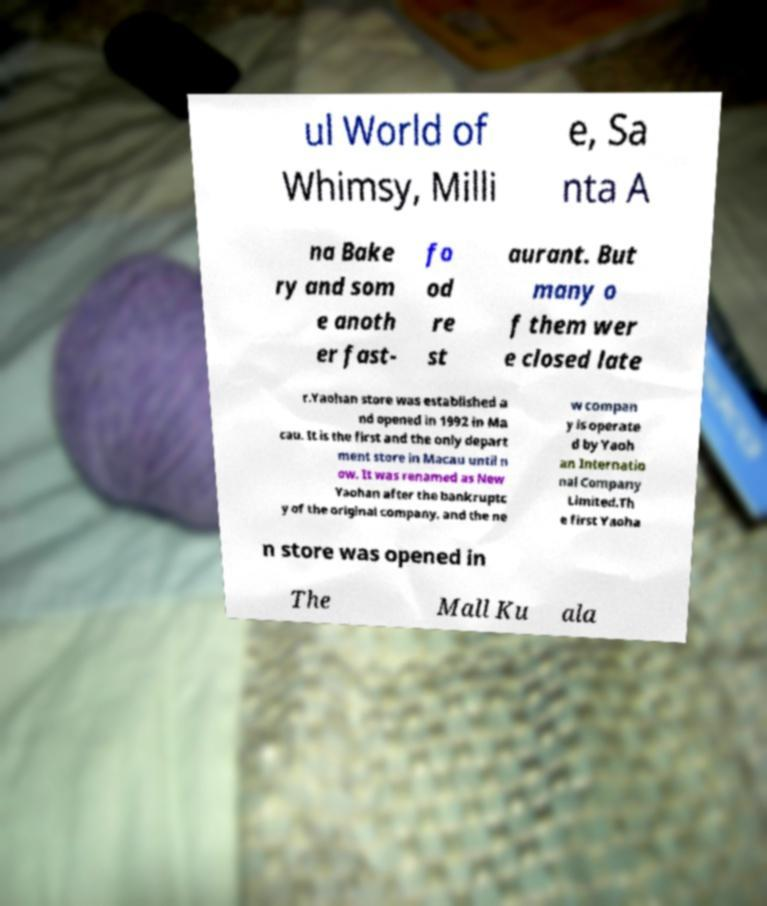There's text embedded in this image that I need extracted. Can you transcribe it verbatim? ul World of Whimsy, Milli e, Sa nta A na Bake ry and som e anoth er fast- fo od re st aurant. But many o f them wer e closed late r.Yaohan store was established a nd opened in 1992 in Ma cau. It is the first and the only depart ment store in Macau until n ow. It was renamed as New Yaohan after the bankruptc y of the original company, and the ne w compan y is operate d by Yaoh an Internatio nal Company Limited.Th e first Yaoha n store was opened in The Mall Ku ala 